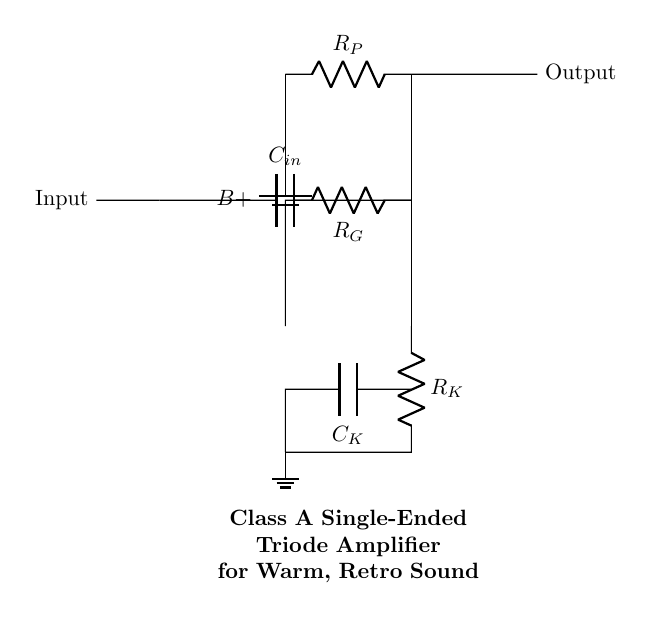What type of amplifier is shown in the circuit? The circuit diagram clearly labels it as a Class A single-ended triode amplifier, indicated by the title at the bottom of the diagram.
Answer: Class A single-ended triode amplifier What is the role of the plate resistor? The plate resistor, labeled R_P in the circuit, is responsible for setting the plate voltage and affecting the gain of the amplifier by controlling the current through the triode tube.
Answer: To set plate voltage and control current How many resistors are present in the circuit? By counting the labeled components, we see R_P (plate resistor), R_K (cathode resistor), and R_G (grid resistor) which means there are three resistors in total.
Answer: Three What is the function of the bypass capacitor? The bypass capacitor, labeled C_K, provides a low-impedance path to ground for AC signals at the cathode, improving gain and stability by effectively isolating the cathode from the AC variations in voltage.
Answer: To improve gain and stability Which component supplies the DC voltage? The component supplying the DC voltage is the battery labeled B+. It is connected to the top of the plate resistor and provides the necessary voltage for the circuit's operation.
Answer: Battery What is the significance of the triode tube in this circuit? The triode tube is the primary amplification component in the circuit, converting the input signal into a larger output signal by utilizing its control grid, cathode, and plate, which are essential for amplification in audio applications.
Answer: Main amplification component What kind of sound is expected from this amplifier design? The design of a Class A single-ended triode amplifier is known for producing a warm, rich sound characteristic, which is highly valued in retro music applications, reflecting the tonal quality desired.
Answer: Warm, retro sound 